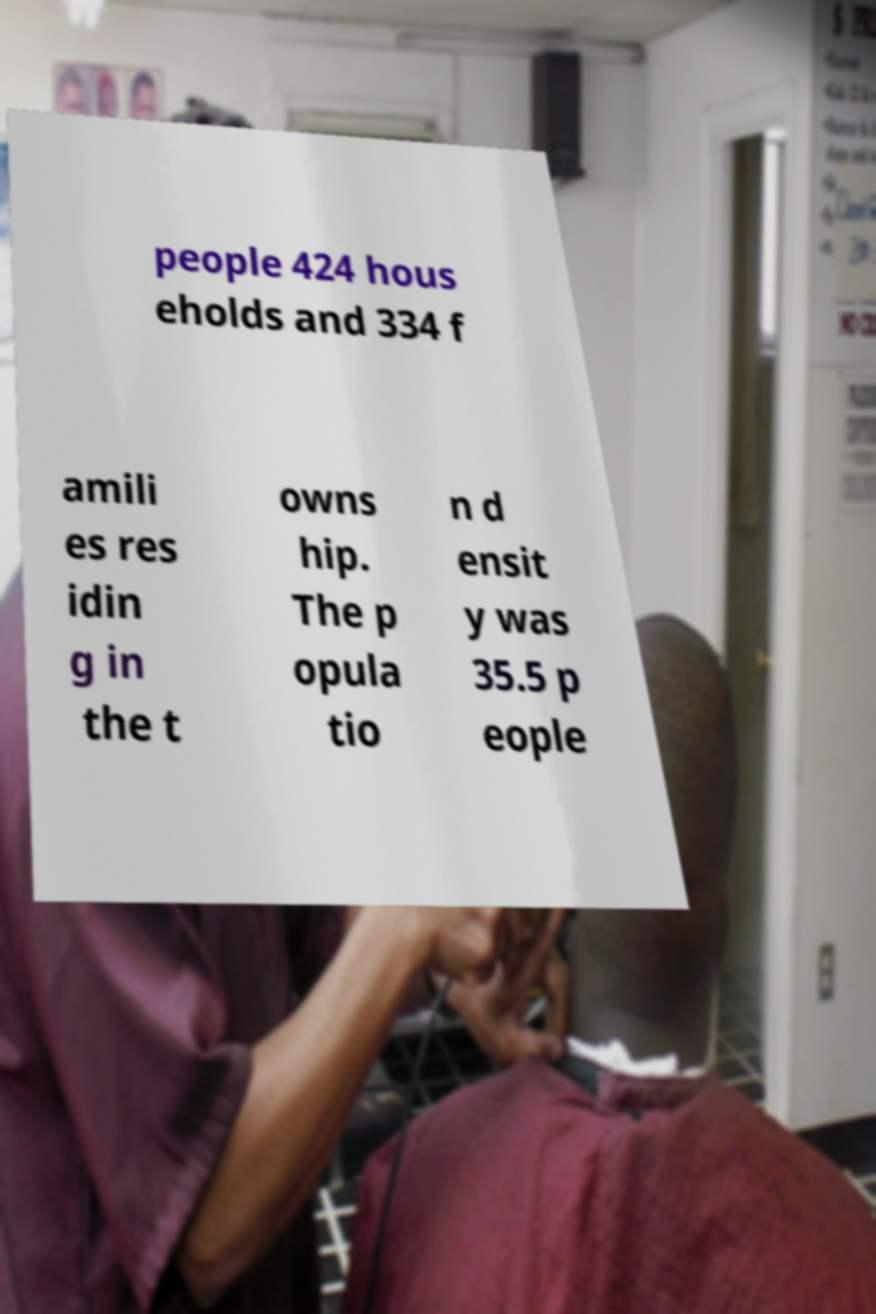Could you assist in decoding the text presented in this image and type it out clearly? people 424 hous eholds and 334 f amili es res idin g in the t owns hip. The p opula tio n d ensit y was 35.5 p eople 